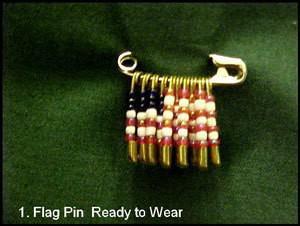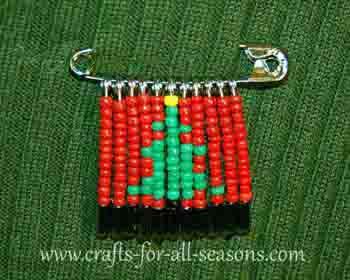The first image is the image on the left, the second image is the image on the right. Considering the images on both sides, is "Left image includes an item made of beads, shaped like a Christmas tree with a star on top." valid? Answer yes or no. No. The first image is the image on the left, the second image is the image on the right. For the images displayed, is the sentence "The pin in the image on the left looks like an American flag." factually correct? Answer yes or no. Yes. 